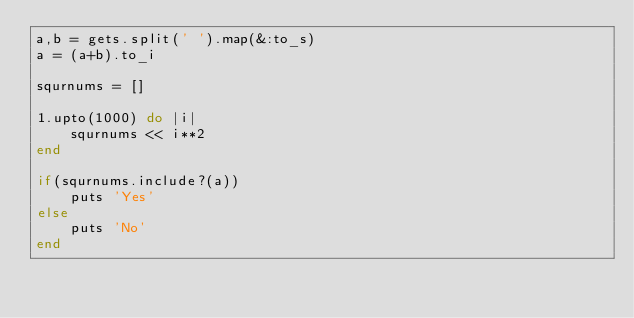Convert code to text. <code><loc_0><loc_0><loc_500><loc_500><_Ruby_>a,b = gets.split(' ').map(&:to_s)
a = (a+b).to_i

squrnums = []

1.upto(1000) do |i|
	squrnums << i**2
end

if(squrnums.include?(a))
	puts 'Yes'
else
	puts 'No'
end</code> 